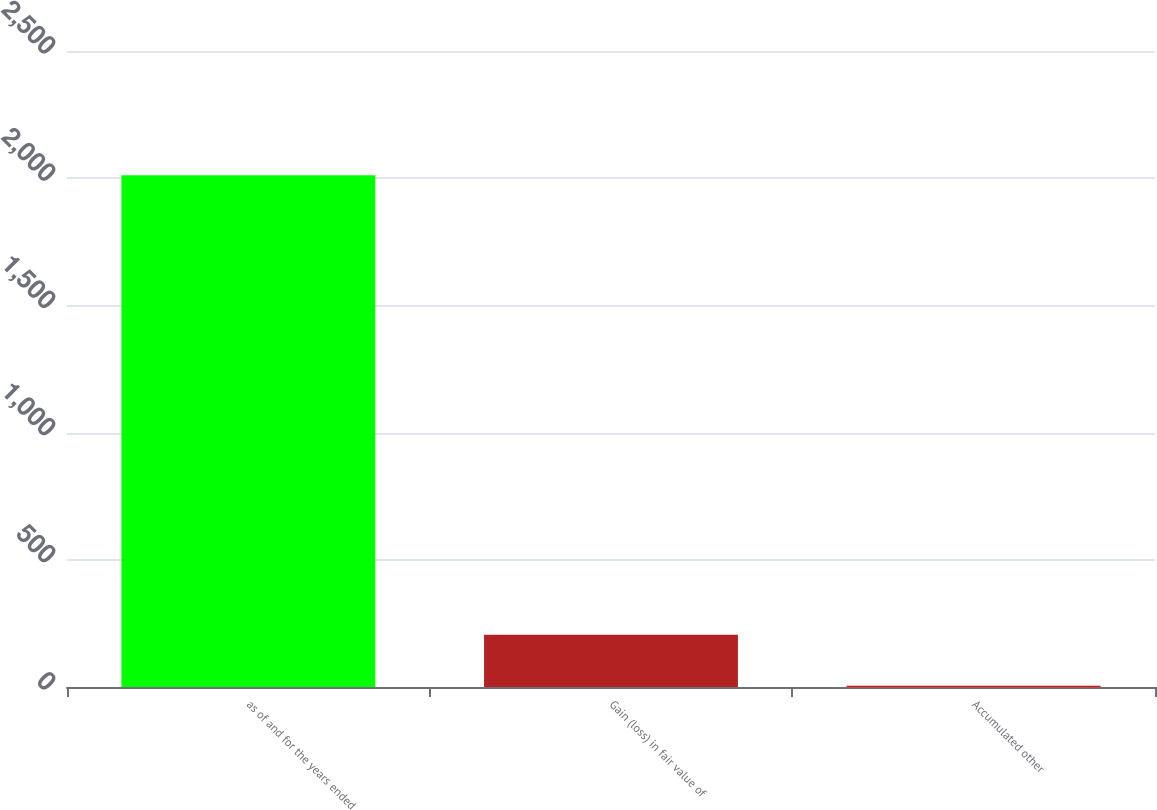Convert chart. <chart><loc_0><loc_0><loc_500><loc_500><bar_chart><fcel>as of and for the years ended<fcel>Gain (loss) in fair value of<fcel>Accumulated other<nl><fcel>2012<fcel>205.7<fcel>5<nl></chart> 